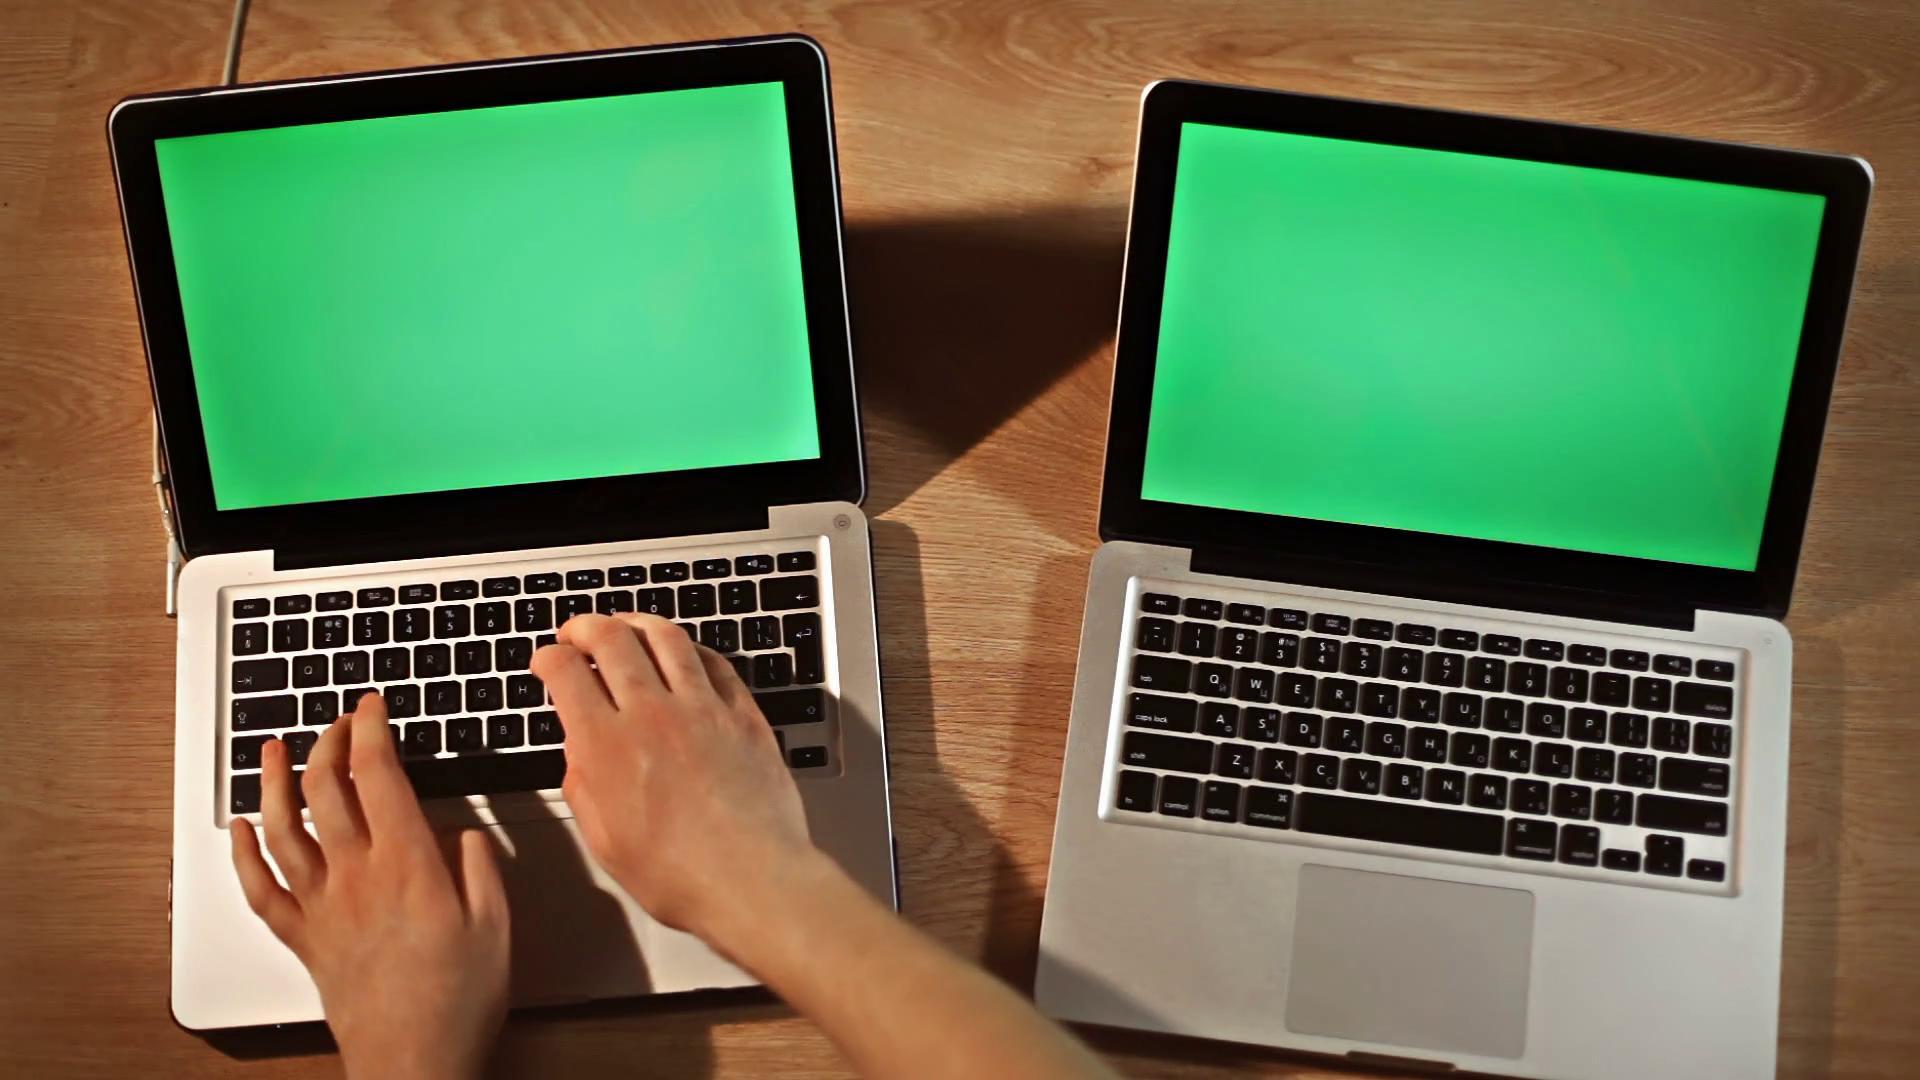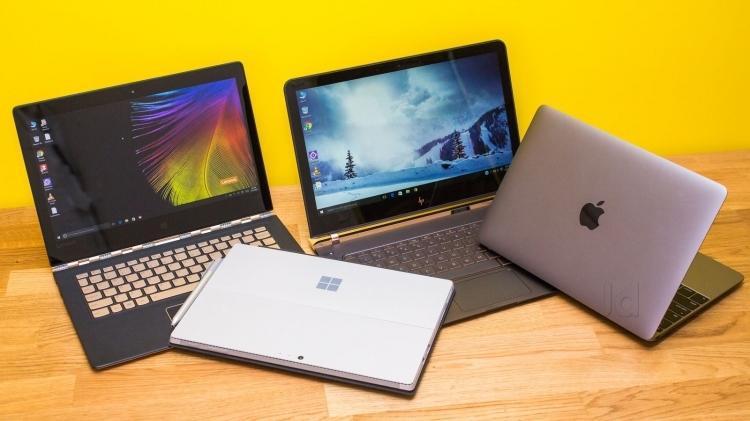The first image is the image on the left, the second image is the image on the right. For the images displayed, is the sentence "In each image, a person's hands are on a laptop keyboard that has black keys on an otherwise light-colored surface." factually correct? Answer yes or no. No. The first image is the image on the left, the second image is the image on the right. For the images shown, is this caption "Each image features a pair of hands over a keyboard, and the right image is an aerial view showing fingers over the black keyboard keys of one laptop." true? Answer yes or no. No. 